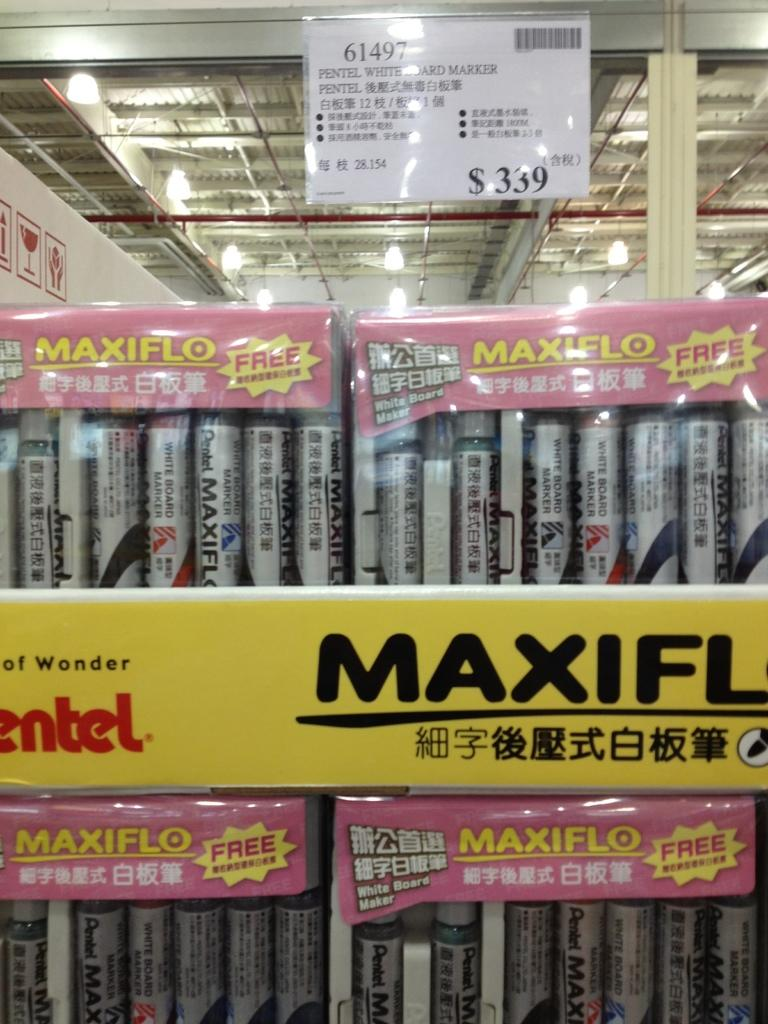Provide a one-sentence caption for the provided image. a display of Maxiflo paint that cost $339. 